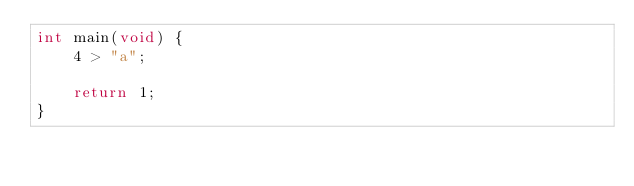<code> <loc_0><loc_0><loc_500><loc_500><_C_>int main(void) {
    4 > "a";

    return 1;
}
</code> 